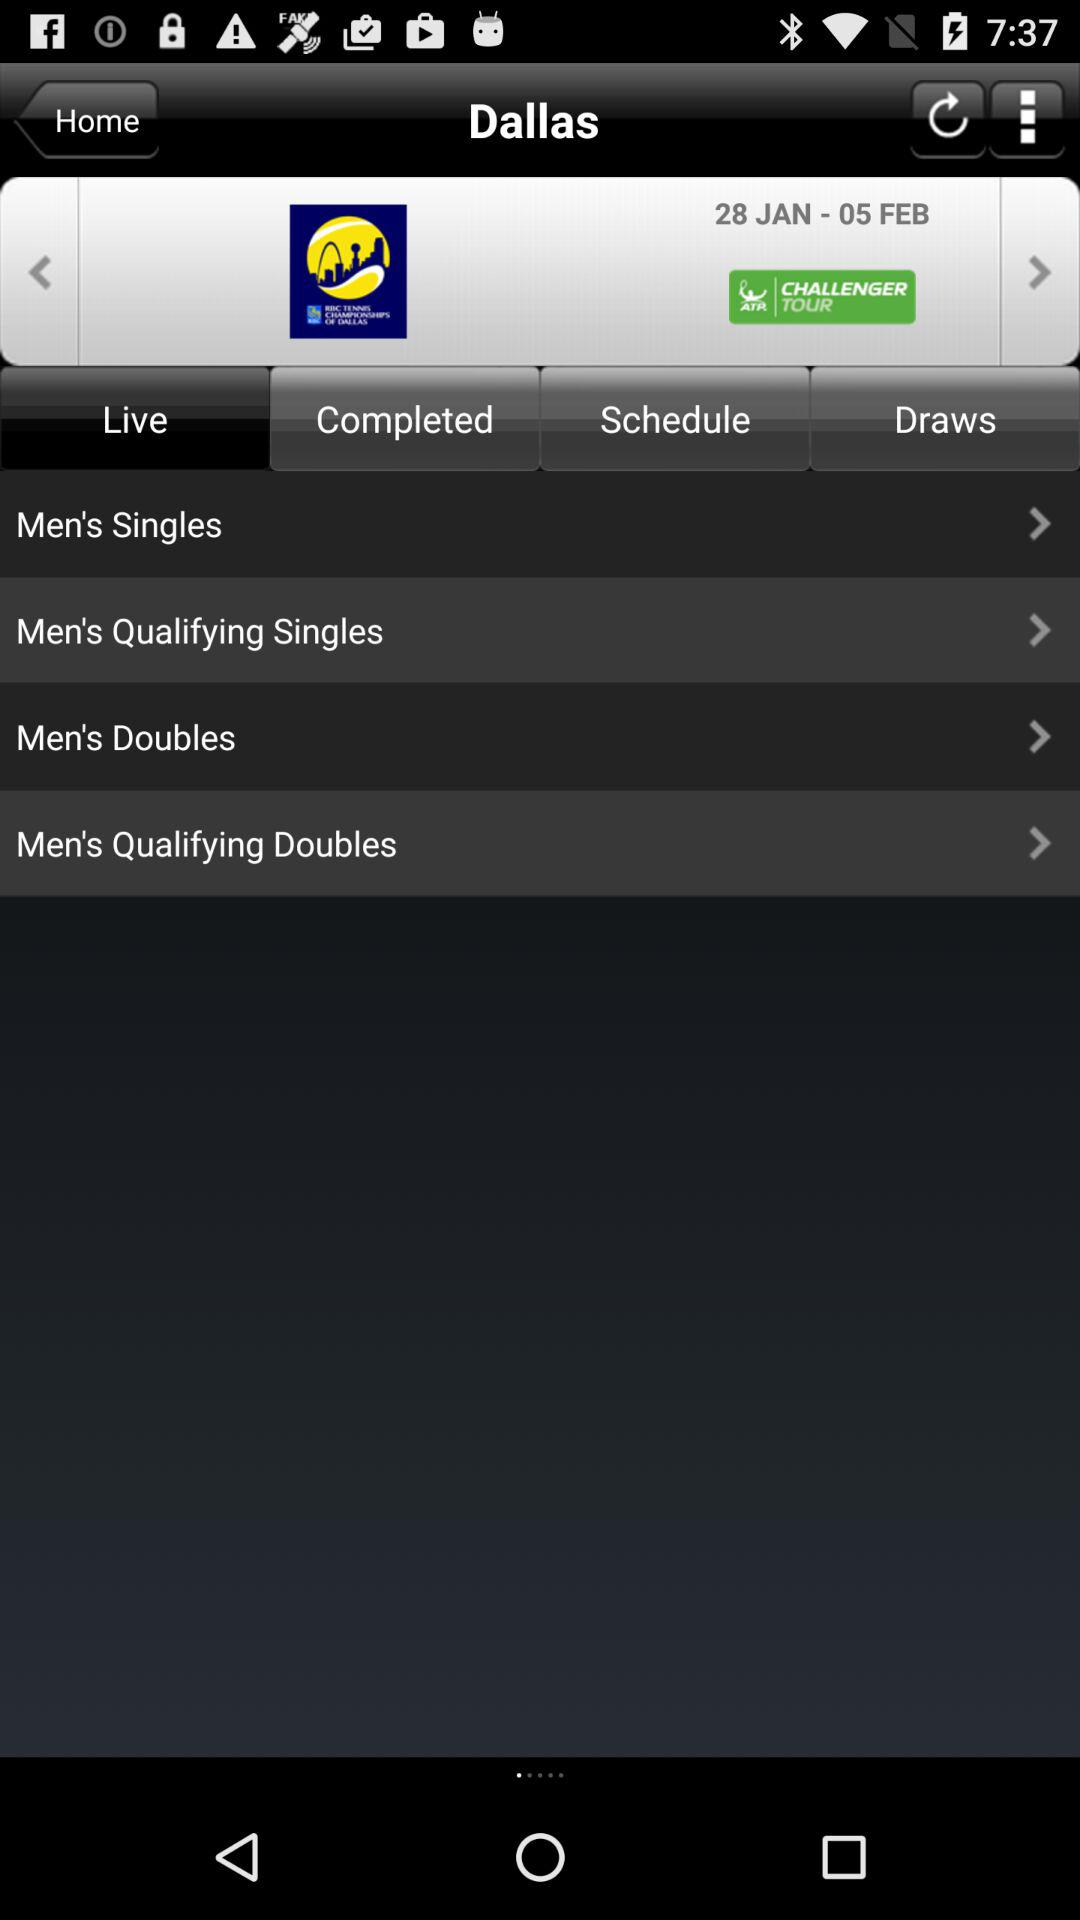Which tab is selected? The selected tab is "Live". 